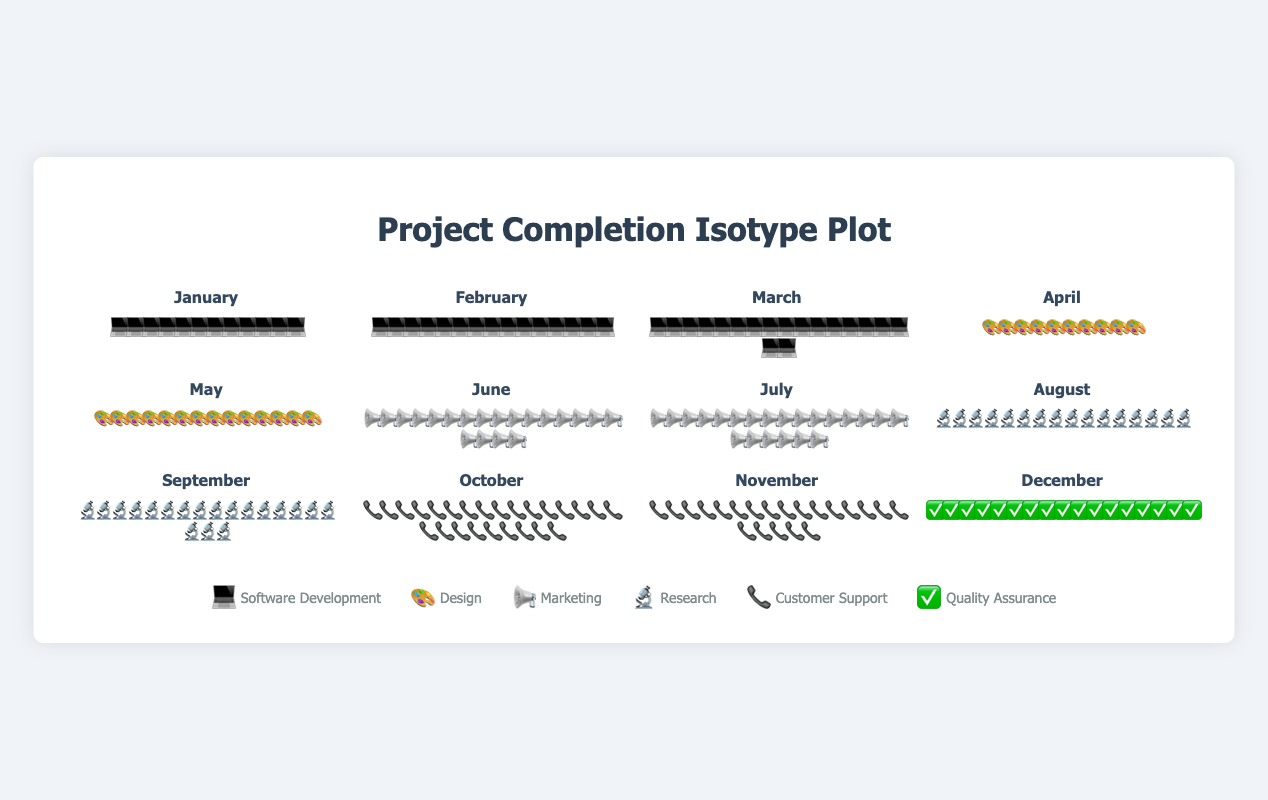What is the total number of projects completed in December? The number of icons in the December section indicates the number of completed projects. Count the number of icons.
Answer: 17 Which month had the highest number of completed projects? Compare the number of icons across all months. The month with the most icons is the one with the highest number of completed projects.
Answer: October How many more projects were completed in March than in January? Count the icons for both January and March. Subtract the number of icons in January from those in March.
Answer: 6 What tasks were predominantly completed in October? Look for the icon type used in October. The legend indicates each icon's corresponding task type.
Answer: Customer Support Which two months had the same number of completed projects? Scan through the figure to find two months with the same number of icons.
Answer: August and December How many software development projects were completed in the first quarter of the year? Identify the icons representing software development and count them for January, February, and March.
Answer: 45 What was the average number of projects completed per month in the second quarter (April to June)? Sum the number of projects for April, May, and June, then divide by 3.
Answer: 14.67 In which month was the highest number of marketing projects completed? Locate the marketing icon in the legend and count the icons for each month. The month with the most marketing icons is the one with the highest number of marketing projects.
Answer: July How many more customer support projects were completed in October than in November? Count the customer support icons in both October and November. Subtract the number in November from the number in October.
Answer: 4 